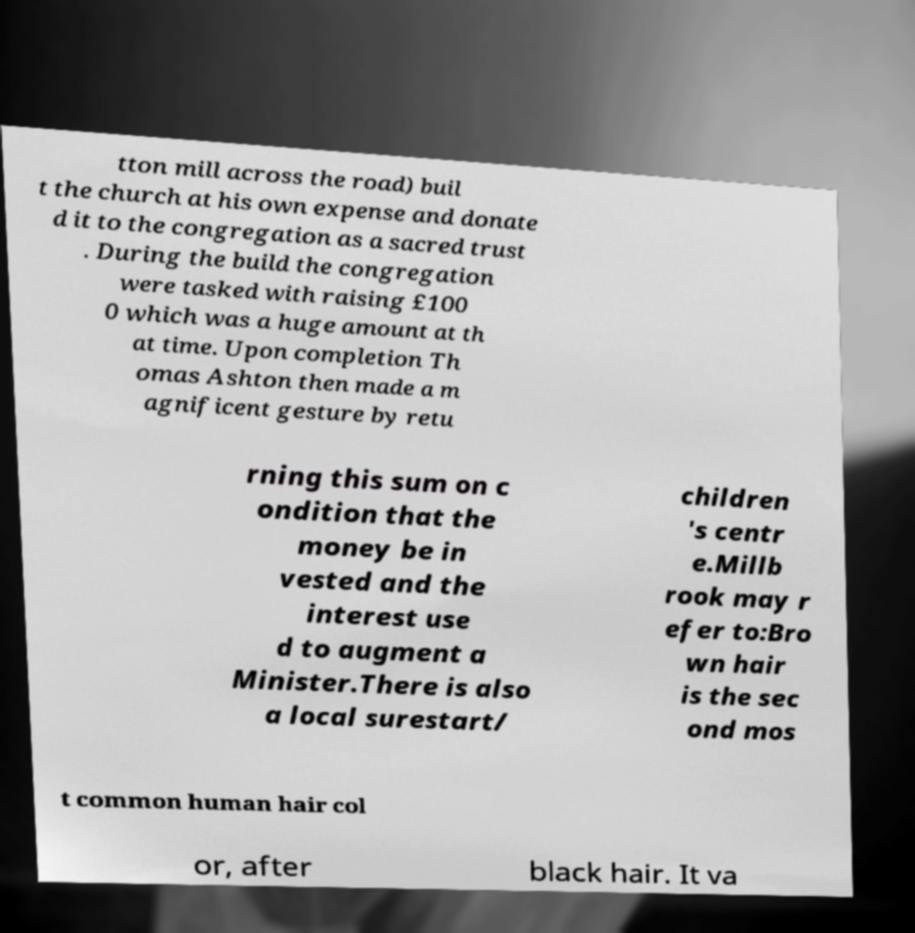I need the written content from this picture converted into text. Can you do that? tton mill across the road) buil t the church at his own expense and donate d it to the congregation as a sacred trust . During the build the congregation were tasked with raising £100 0 which was a huge amount at th at time. Upon completion Th omas Ashton then made a m agnificent gesture by retu rning this sum on c ondition that the money be in vested and the interest use d to augment a Minister.There is also a local surestart/ children 's centr e.Millb rook may r efer to:Bro wn hair is the sec ond mos t common human hair col or, after black hair. It va 